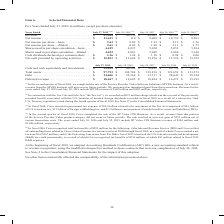According to Cisco Systems's financial document, Which sale did the company complete in the second quarter of fiscal 2019? the sale of the Service Provider Video Software Solutions (SPVSS) business.. The document states: "In the second quarter of fiscal 2019, we completed the sale of the Service Provider Video Software Solutions (SPVSS) business. As a result, revenue fr..." Also, What was the SPVSS revenue in 2019? According to the financial document, $168 million. The relevant text states: "7, 2019 and July 28, 2018 include SPVSS revenue of $168 million and $903 million, respectively...." Also, Which years does the table provide information for Revenue? The document contains multiple relevant values: 2019, 2018, 2017, 2016, 2015. From the document: "Years Ended July 27, 2019 (1)(2) July 28, 2018 (1)(3) July 29, 2017 July 30, 2016 (4)(5) July 25, 2015 (4) Years Ended July 27, 2019 (1)(2) July 28, 2..." Also, How many years did Revenue exceed $50,000 million? Based on the analysis, there are 1 instances. The counting process: 2019. Also, can you calculate: What was the change in the basic shares used in per-share calculation between 2018 and 2019? Based on the calculation: 4,419-4,837, the result is -418 (in millions). This is based on the information: "1.75 Shares used in per-share calculation—basic . 4,419 4,837 5,010 5,053 5,104 Shares used in per-share calculation—diluted . 4,453 4,881 5,049 5,088 5,14 hares used in per-share calculation—basic . ..." The key data points involved are: 4,419, 4,837. Also, can you calculate: What was the percentage change in the  Net cash provided by operating activities  between 2017 and 2018? To answer this question, I need to perform calculations using the financial data. The calculation is: (13,666-13,876)/13,876, which equals -1.51 (percentage). This is based on the information: "ded by operating activities . $ 15,831 $ 13,666 $ 13,876 $ 13,570 $ 12,552 ash provided by operating activities . $ 15,831 $ 13,666 $ 13,876 $ 13,570 $ 12,552..." The key data points involved are: 13,666, 13,876. 